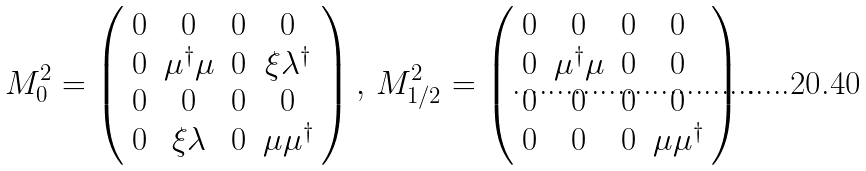Convert formula to latex. <formula><loc_0><loc_0><loc_500><loc_500>M _ { 0 } ^ { 2 } = \left ( \begin{array} { c c c c } 0 & 0 & 0 & 0 \\ 0 & \mu ^ { \dagger } \mu & 0 & \xi \lambda ^ { \dagger } \\ 0 & 0 & 0 & 0 \\ 0 & \xi \lambda & 0 & \mu \mu ^ { \dagger } \end{array} \right ) , \, M _ { 1 / 2 } ^ { 2 } = \left ( \begin{array} { c c c c } 0 & 0 & 0 & 0 \\ 0 & \mu ^ { \dagger } \mu & 0 & 0 \\ 0 & 0 & 0 & 0 \\ 0 & 0 & 0 & \mu \mu ^ { \dagger } \end{array} \right ) .</formula> 